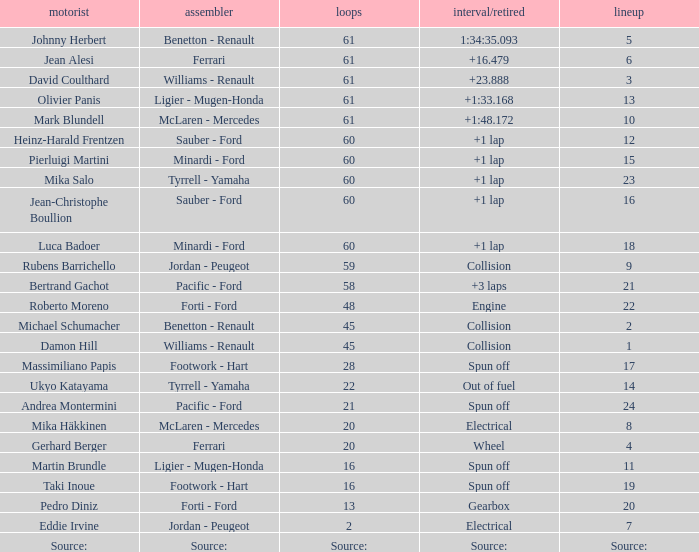Can you give me this table as a dict? {'header': ['motorist', 'assembler', 'loops', 'interval/retired', 'lineup'], 'rows': [['Johnny Herbert', 'Benetton - Renault', '61', '1:34:35.093', '5'], ['Jean Alesi', 'Ferrari', '61', '+16.479', '6'], ['David Coulthard', 'Williams - Renault', '61', '+23.888', '3'], ['Olivier Panis', 'Ligier - Mugen-Honda', '61', '+1:33.168', '13'], ['Mark Blundell', 'McLaren - Mercedes', '61', '+1:48.172', '10'], ['Heinz-Harald Frentzen', 'Sauber - Ford', '60', '+1 lap', '12'], ['Pierluigi Martini', 'Minardi - Ford', '60', '+1 lap', '15'], ['Mika Salo', 'Tyrrell - Yamaha', '60', '+1 lap', '23'], ['Jean-Christophe Boullion', 'Sauber - Ford', '60', '+1 lap', '16'], ['Luca Badoer', 'Minardi - Ford', '60', '+1 lap', '18'], ['Rubens Barrichello', 'Jordan - Peugeot', '59', 'Collision', '9'], ['Bertrand Gachot', 'Pacific - Ford', '58', '+3 laps', '21'], ['Roberto Moreno', 'Forti - Ford', '48', 'Engine', '22'], ['Michael Schumacher', 'Benetton - Renault', '45', 'Collision', '2'], ['Damon Hill', 'Williams - Renault', '45', 'Collision', '1'], ['Massimiliano Papis', 'Footwork - Hart', '28', 'Spun off', '17'], ['Ukyo Katayama', 'Tyrrell - Yamaha', '22', 'Out of fuel', '14'], ['Andrea Montermini', 'Pacific - Ford', '21', 'Spun off', '24'], ['Mika Häkkinen', 'McLaren - Mercedes', '20', 'Electrical', '8'], ['Gerhard Berger', 'Ferrari', '20', 'Wheel', '4'], ['Martin Brundle', 'Ligier - Mugen-Honda', '16', 'Spun off', '11'], ['Taki Inoue', 'Footwork - Hart', '16', 'Spun off', '19'], ['Pedro Diniz', 'Forti - Ford', '13', 'Gearbox', '20'], ['Eddie Irvine', 'Jordan - Peugeot', '2', 'Electrical', '7'], ['Source:', 'Source:', 'Source:', 'Source:', 'Source:']]} How many laps does luca badoer have? 60.0. 